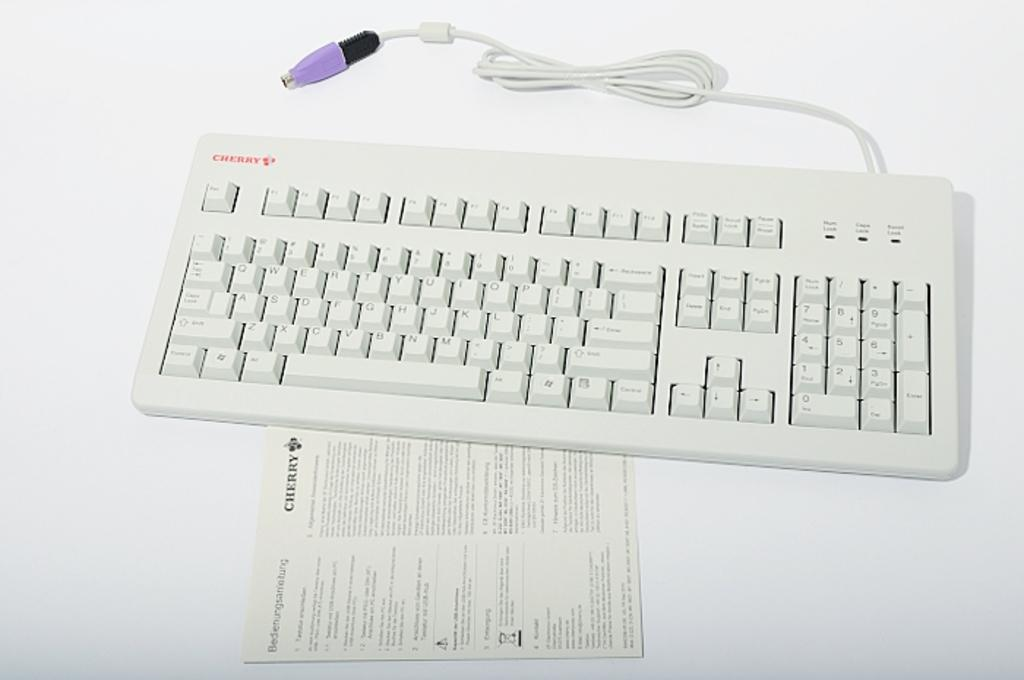What is the main object in the center of the image? There is a keyboard in the image, and it is in the center. What other object is present in the center of the image? There is a paper in the image, along with the keyboard. What color is the copper chess piece on the keyboard? There is no copper chess piece present on the keyboard in the image. 